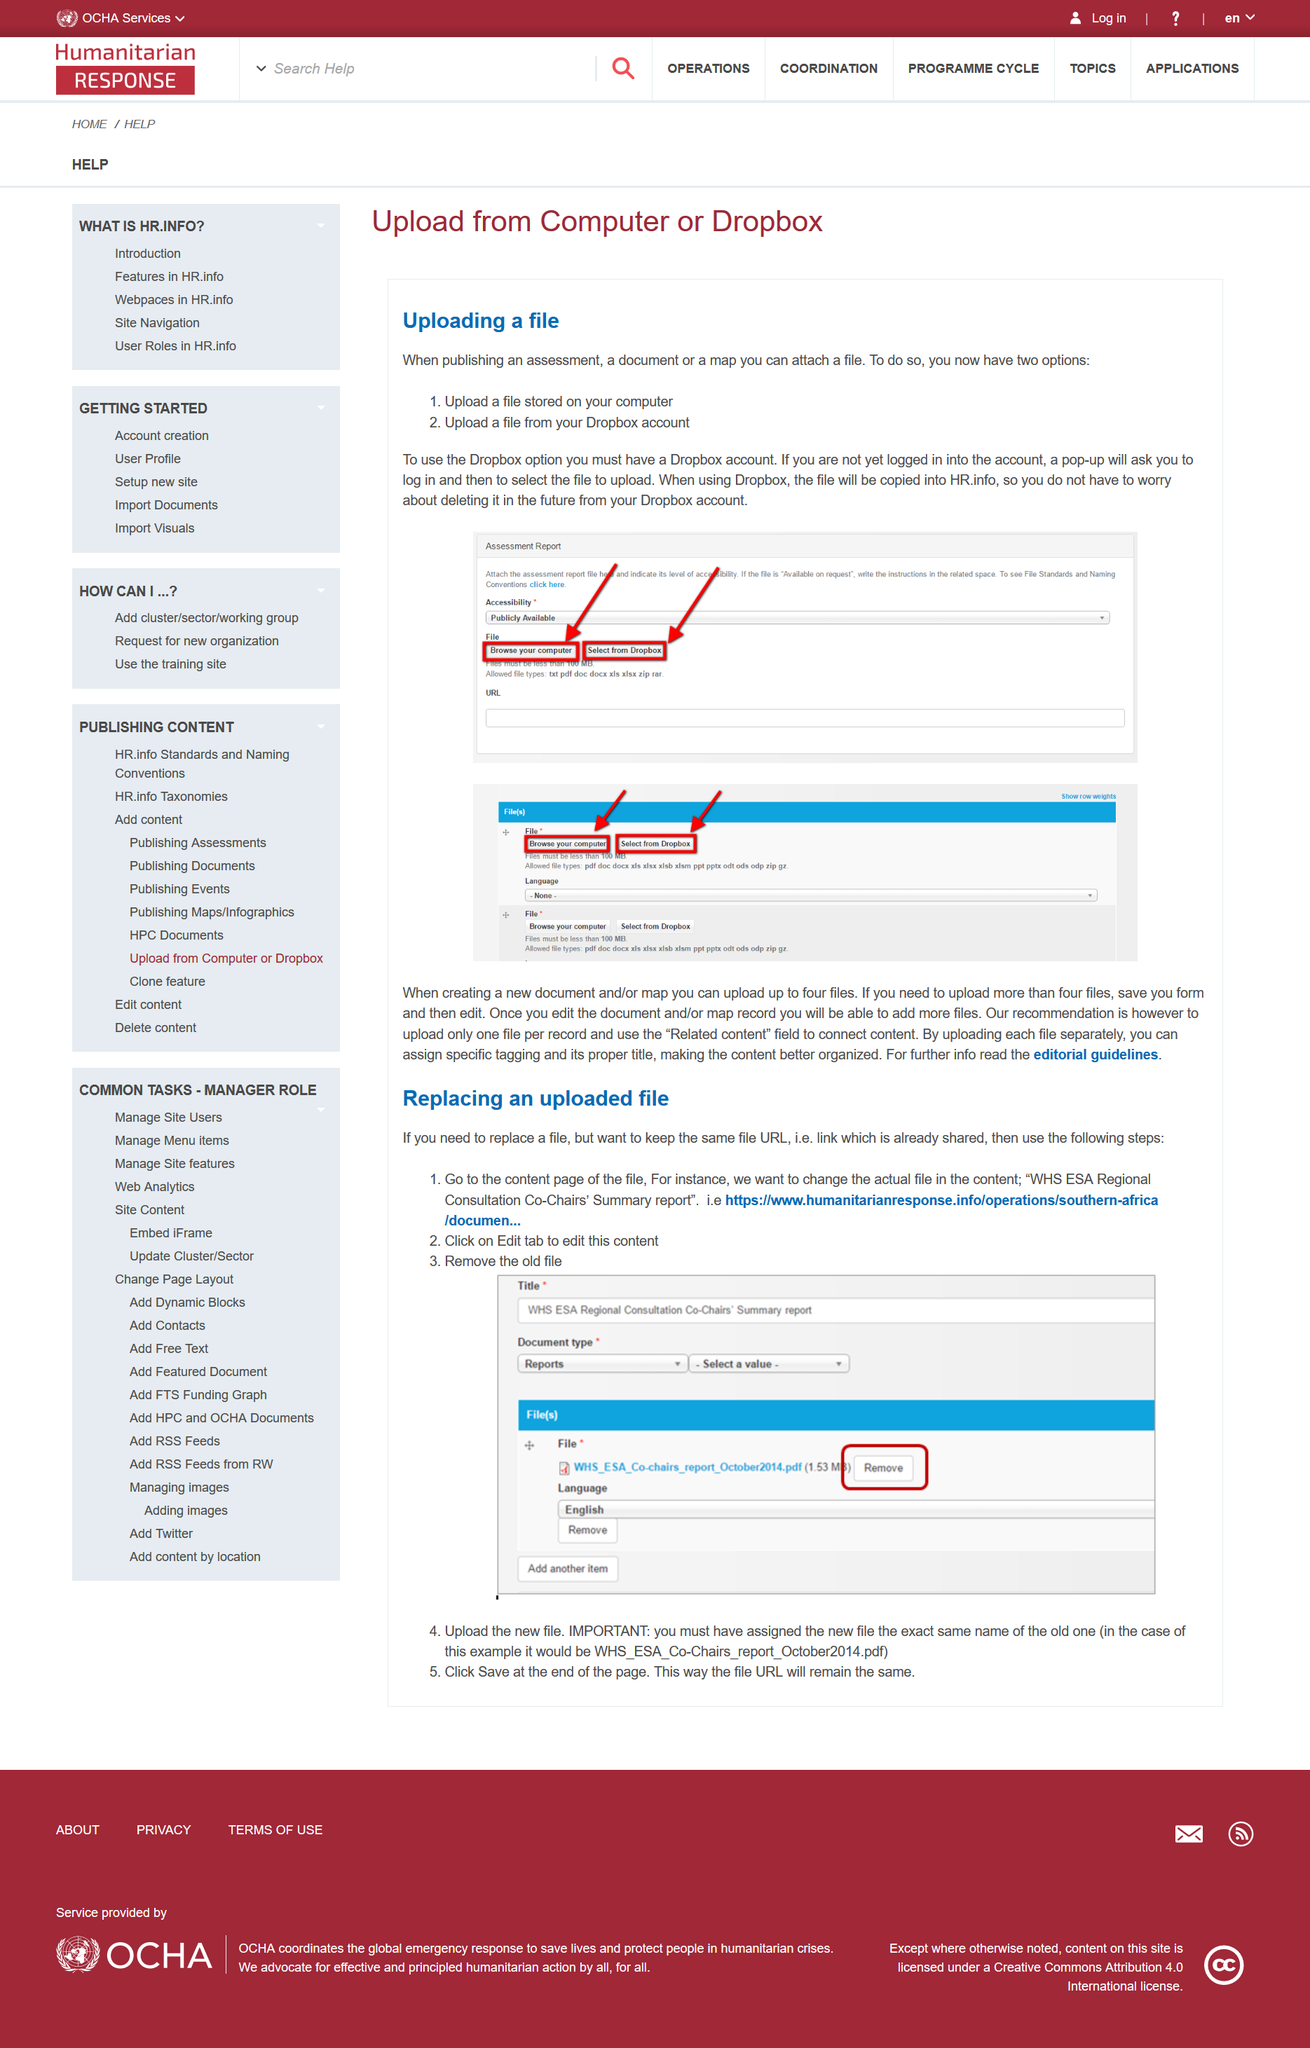Identify some key points in this picture. When creating a new document or map, a maximum of four files can be uploaded at once. A file can be uploaded from either your computer or your Dropbox account to two locations. If a file is uploaded to HR.info from Dropbox and later deleted from Dropbox, it will not also be removed from HR.info. The final stage in the process is to click on "Save" at the end of the page in order to ensure that the URL remains the same. After accessing the content page of the file, and before closing the input stream, the old file should be removed. 